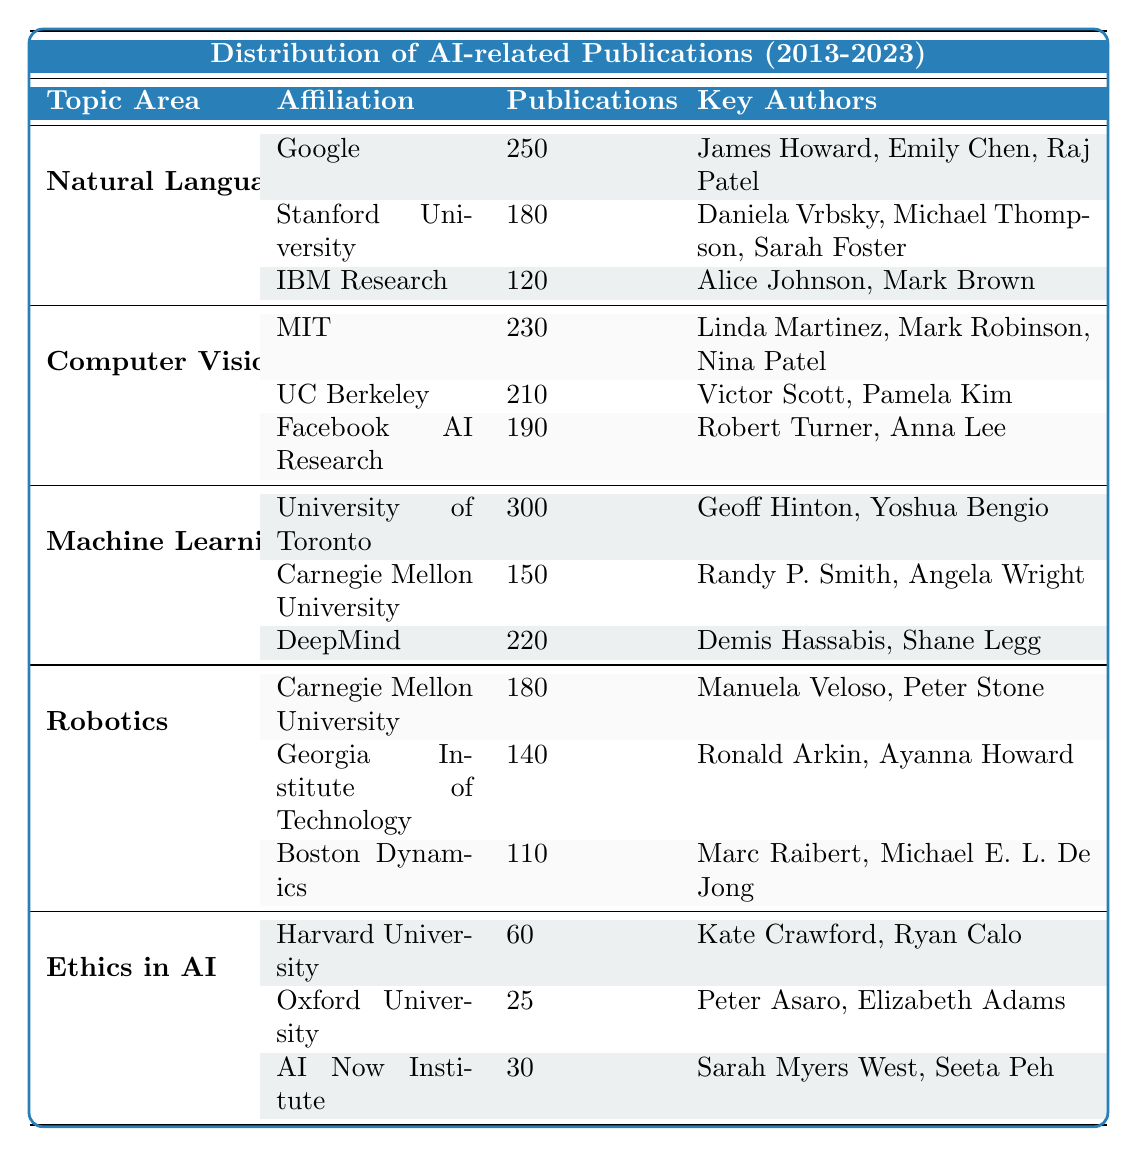What is the total number of publications in Machine Learning? The table lists 300 publications from the University of Toronto, 150 from Carnegie Mellon University, and 220 from DeepMind in the Machine Learning topic area. Adding these together: 300 + 150 + 220 = 670.
Answer: 670 Which institution published the most papers in Natural Language Processing? According to the table, Google published 250 papers, Stanford University published 180 papers, and IBM Research published 120 papers. Google has the highest count of publications in this area.
Answer: Google How many total publications are there across all topic areas? Counting the publications from each topic area: Natural Language Processing (250 + 180 + 120 = 550), Computer Vision (230 + 210 + 190 = 630), Machine Learning (300 + 150 + 220 = 670), Robotics (180 + 140 + 110 = 430), and Ethics in AI (60 + 25 + 30 = 115). Summing these results: 550 + 630 + 670 + 430 + 115 = 2495.
Answer: 2495 Is DeepMind among the top three institutions in terms of the number of publications in Machine Learning? DeepMind published 220 papers in the Machine Learning category. The highest number is from the University of Toronto (300), and the second highest is 220 from DeepMind, making it tied for second place along with Carnegie Mellon University (150). Therefore, DeepMind is among the top three.
Answer: Yes What is the average number of publications for the topic area Robotics? In Robotics, Carnegie Mellon University published 180, Georgia Institute of Technology 140, and Boston Dynamics 110. The total is 180 + 140 + 110 = 430. There are 3 institutions, so the average is 430 / 3 = approximately 143.33.
Answer: 143.33 Which topic area has the highest total publication count? The total publication counts are: Natural Language Processing (550), Computer Vision (630), Machine Learning (670), Robotics (430), and Ethics in AI (115). Machine Learning has the highest count of 670.
Answer: Machine Learning Are there more publications from Google than the combined total of publications from Harvard University and Oxford University in Ethics in AI? Google has 250 publications in Natural Language Processing, while Harvard University published 60 and Oxford University 25 in Ethics in AI. Combined, Harvard and Oxford published 60 + 25 = 85. Comparing these, 250 (Google) is greater than 85.
Answer: Yes 